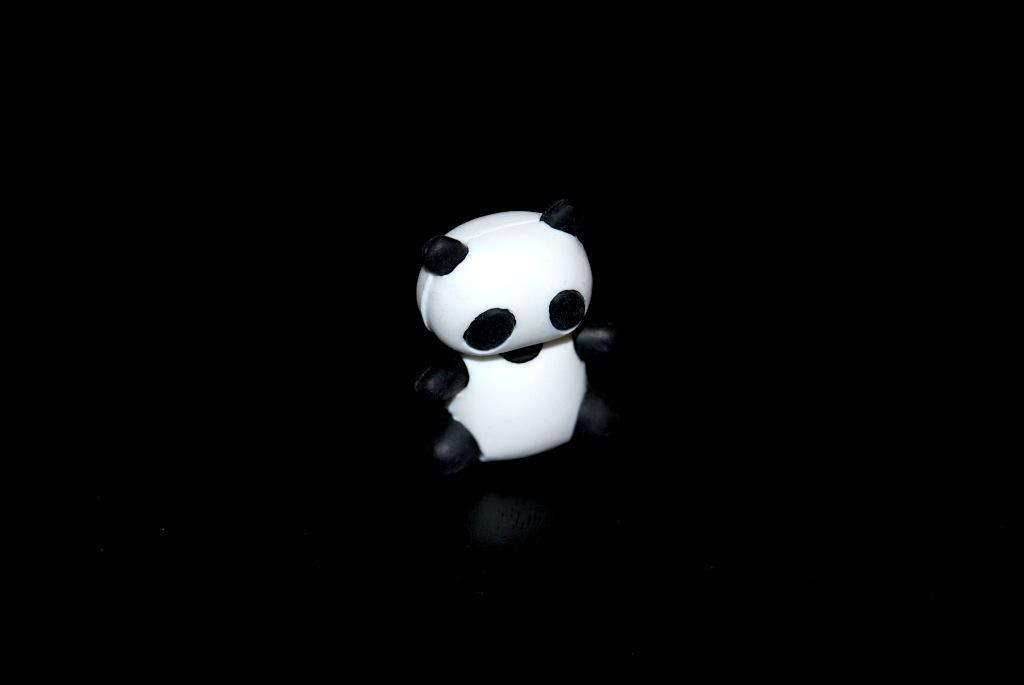What is the main subject in the middle of the image? There is a toy in the middle of the image. What can be said about the background of the image? The background of the image is dark. Can you tell me why the volcano is erupting in the image? There is no volcano present in the image, so it cannot be determined why it would be erupting. What type of key is visible in the image? There is no key present in the image. 